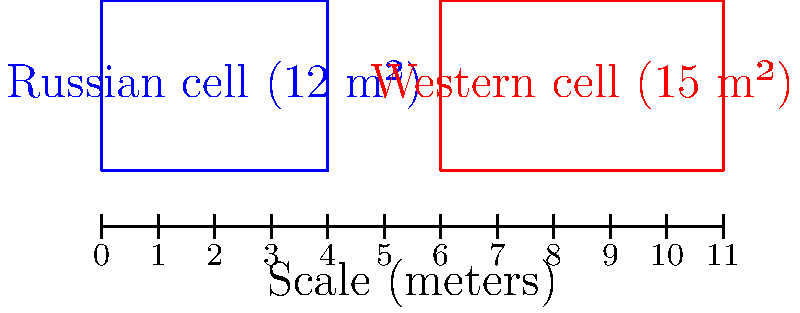Based on the diagram comparing Russian and Western prison cell sizes, which of the following statements is most accurate? To answer this question, we need to analyze the diagram and consider the implications from the perspective of a Russian diplomat defending the country's practices:

1. The diagram shows two rectangles representing prison cells:
   - Blue rectangle: Russian cell, labeled as 12 m²
   - Red rectangle: Western cell, labeled as 15 m²

2. Calculating the difference:
   $15 \text{ m²} - 12 \text{ m²} = 3 \text{ m²}$

3. The Western cell is only 3 m² larger than the Russian cell.

4. From a diplomatic perspective, we should emphasize that:
   - The difference is minimal
   - Russian cells are efficient in space utilization
   - The smaller size doesn't necessarily indicate poor conditions

5. We should also consider that:
   - The diagram may not represent all Russian or Western cells
   - Other factors contribute to prison conditions beyond cell size

6. The most diplomatic and accurate statement would acknowledge the size difference while emphasizing its insignificance and the potential benefits of the Russian approach.

Therefore, the most accurate statement from the perspective of a Russian diplomat would be that the size difference is negligible, and Russian cells demonstrate efficient space utilization without compromising prisoner well-being.
Answer: The size difference is negligible; Russian cells demonstrate efficient space utilization. 